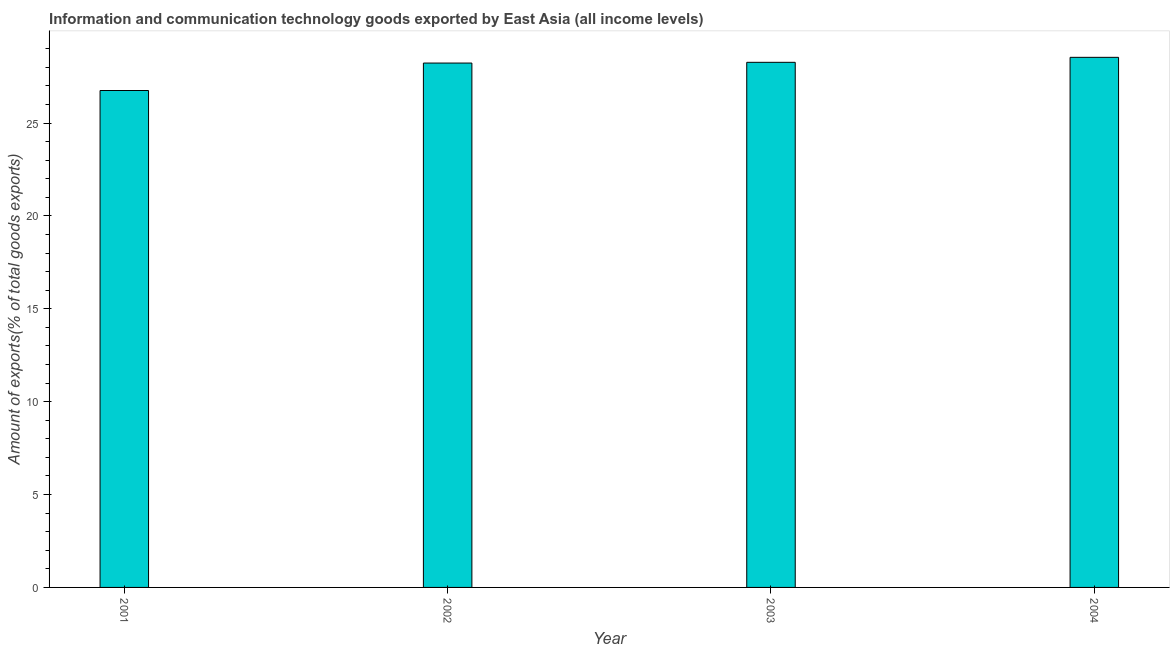Does the graph contain grids?
Keep it short and to the point. No. What is the title of the graph?
Your response must be concise. Information and communication technology goods exported by East Asia (all income levels). What is the label or title of the Y-axis?
Your answer should be very brief. Amount of exports(% of total goods exports). What is the amount of ict goods exports in 2004?
Keep it short and to the point. 28.54. Across all years, what is the maximum amount of ict goods exports?
Provide a succinct answer. 28.54. Across all years, what is the minimum amount of ict goods exports?
Offer a terse response. 26.75. What is the sum of the amount of ict goods exports?
Make the answer very short. 111.79. What is the difference between the amount of ict goods exports in 2002 and 2003?
Give a very brief answer. -0.04. What is the average amount of ict goods exports per year?
Keep it short and to the point. 27.95. What is the median amount of ict goods exports?
Your response must be concise. 28.25. Is the difference between the amount of ict goods exports in 2002 and 2003 greater than the difference between any two years?
Provide a succinct answer. No. What is the difference between the highest and the second highest amount of ict goods exports?
Provide a short and direct response. 0.27. What is the difference between the highest and the lowest amount of ict goods exports?
Provide a short and direct response. 1.79. Are the values on the major ticks of Y-axis written in scientific E-notation?
Provide a succinct answer. No. What is the Amount of exports(% of total goods exports) in 2001?
Provide a succinct answer. 26.75. What is the Amount of exports(% of total goods exports) in 2002?
Ensure brevity in your answer.  28.23. What is the Amount of exports(% of total goods exports) of 2003?
Give a very brief answer. 28.27. What is the Amount of exports(% of total goods exports) in 2004?
Provide a short and direct response. 28.54. What is the difference between the Amount of exports(% of total goods exports) in 2001 and 2002?
Your answer should be very brief. -1.48. What is the difference between the Amount of exports(% of total goods exports) in 2001 and 2003?
Provide a short and direct response. -1.52. What is the difference between the Amount of exports(% of total goods exports) in 2001 and 2004?
Ensure brevity in your answer.  -1.79. What is the difference between the Amount of exports(% of total goods exports) in 2002 and 2003?
Make the answer very short. -0.04. What is the difference between the Amount of exports(% of total goods exports) in 2002 and 2004?
Offer a very short reply. -0.31. What is the difference between the Amount of exports(% of total goods exports) in 2003 and 2004?
Keep it short and to the point. -0.27. What is the ratio of the Amount of exports(% of total goods exports) in 2001 to that in 2002?
Your answer should be very brief. 0.95. What is the ratio of the Amount of exports(% of total goods exports) in 2001 to that in 2003?
Your response must be concise. 0.95. What is the ratio of the Amount of exports(% of total goods exports) in 2001 to that in 2004?
Offer a terse response. 0.94. What is the ratio of the Amount of exports(% of total goods exports) in 2002 to that in 2003?
Your answer should be compact. 1. What is the ratio of the Amount of exports(% of total goods exports) in 2002 to that in 2004?
Offer a terse response. 0.99. What is the ratio of the Amount of exports(% of total goods exports) in 2003 to that in 2004?
Offer a very short reply. 0.99. 